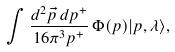Convert formula to latex. <formula><loc_0><loc_0><loc_500><loc_500>\int \frac { d ^ { 2 } \vec { p } \, d p ^ { + } } { 1 6 \pi ^ { 3 } p ^ { + } } \, \Phi ( p ) | p , \lambda \rangle ,</formula> 